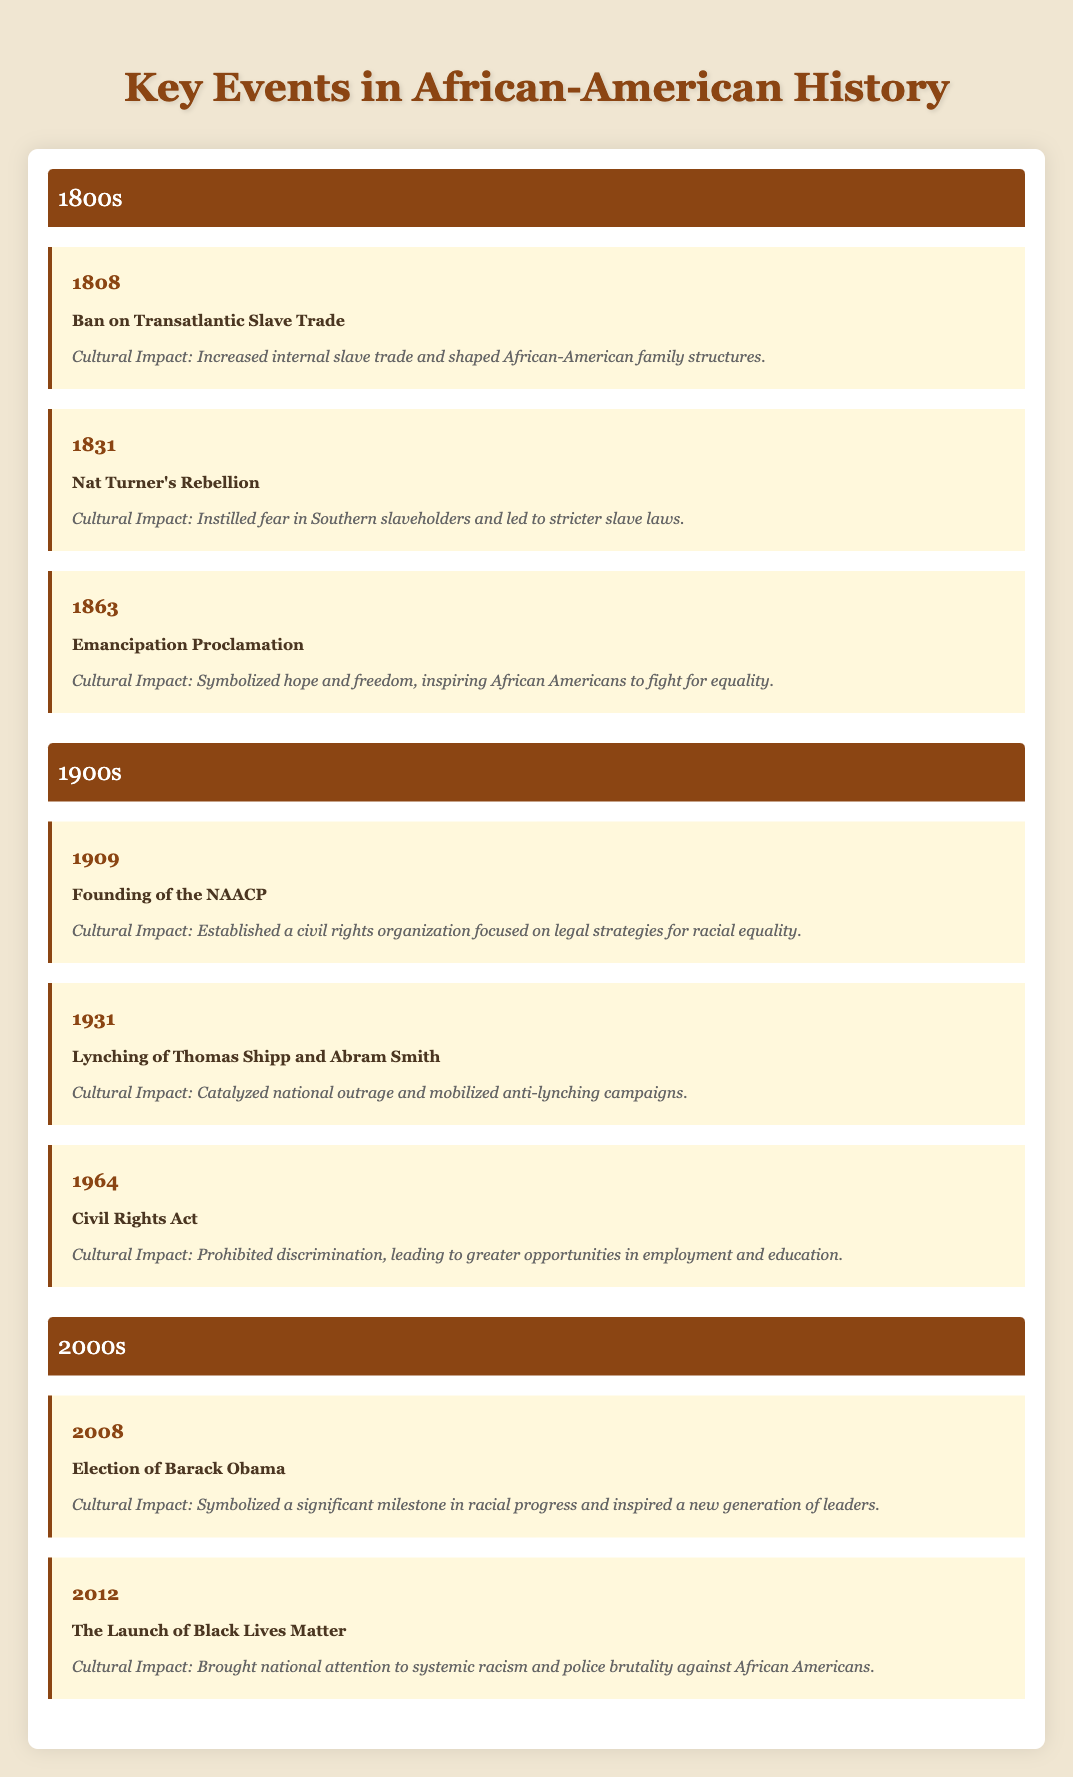What was the first event listed in the 1800s? The first event in the 1800s is the Ban on Transatlantic Slave Trade, which occurred in 1808.
Answer: Ban on Transatlantic Slave Trade How many key events were noted in the 1900s? There are three key events listed in the 1900s: the Founding of the NAACP in 1909, the Lynching of Thomas Shipp and Abram Smith in 1931, and the Civil Rights Act in 1964.
Answer: Three Did the Emancipation Proclamation occur before or after Nat Turner's Rebellion? The Emancipation Proclamation occurred after Nat Turner's Rebellion; Nat Turner's Rebellion was in 1831 and the Emancipation Proclamation was in 1863.
Answer: After What cultural impact is associated with the founding of the NAACP? The founding of the NAACP established a civil rights organization focused on legal strategies for racial equality, which is the cultural impact noted for that event.
Answer: Established a civil rights organization Which event occurred in 2012, and what was its cultural impact? The event that occurred in 2012 was the Launch of Black Lives Matter. Its cultural impact was that it brought national attention to systemic racism and police brutality against African Americans.
Answer: Launch of Black Lives Matter, brought national attention to systemic racism What was the difference in years between the election of Barack Obama and the founding of the NAACP? The election of Barack Obama occurred in 2008 and the founding of the NAACP occurred in 1909. The difference in years is calculated as 2008 - 1909 = 99 years.
Answer: 99 years Was the Civil Rights Act passed before or after the lynching of Thomas Shipp and Abram Smith? The Civil Rights Act was passed after the lynching of Thomas Shipp and Abram Smith. The lynching happened in 1931 and the Civil Rights Act was passed in 1964.
Answer: After What are the cultural impacts of the events in the 2000s combined? The cultural impacts are (1) the election of Barack Obama symbolized a significant milestone in racial progress, and (2) the launch of Black Lives Matter raised awareness of systemic racism. Together, they signify major progress and activism in African-American history.
Answer: Symbolized racial progress and raised awareness of racism Which decade featured the Emancipation Proclamation? The Emancipation Proclamation was featured in the 1860s, specifically in the year 1863.
Answer: 1860s Did Nat Turner's Rebellion lead to looser or stricter slave laws? Nat Turner's Rebellion led to stricter slave laws, as it instilled fear in Southern slaveholders and prompted them to enforce more rigid controls.
Answer: Stricter slave laws 